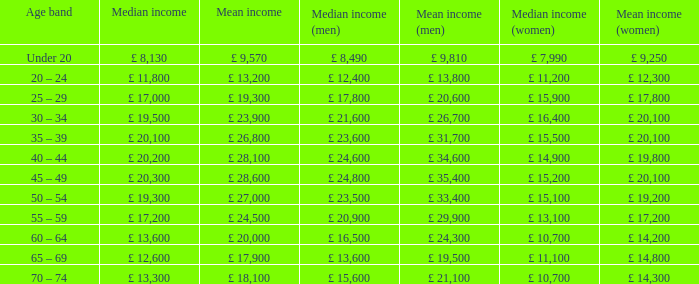Identify the middle income for individuals under 20 years old. £ 8,130. 